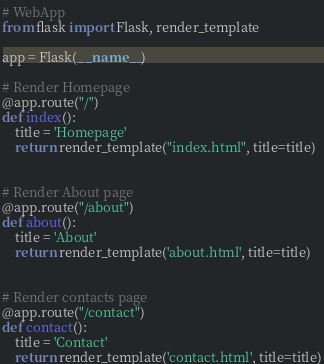Convert code to text. <code><loc_0><loc_0><loc_500><loc_500><_Python_># WebApp
from flask import Flask, render_template

app = Flask(__name__)

# Render Homepage
@app.route("/")
def index():
    title = 'Homepage'
    return render_template("index.html", title=title)


# Render About page
@app.route("/about")
def about():
    title = 'About'
    return render_template('about.html', title=title)


# Render contacts page
@app.route("/contact")
def contact():
    title = 'Contact'
    return render_template('contact.html', title=title)
</code> 